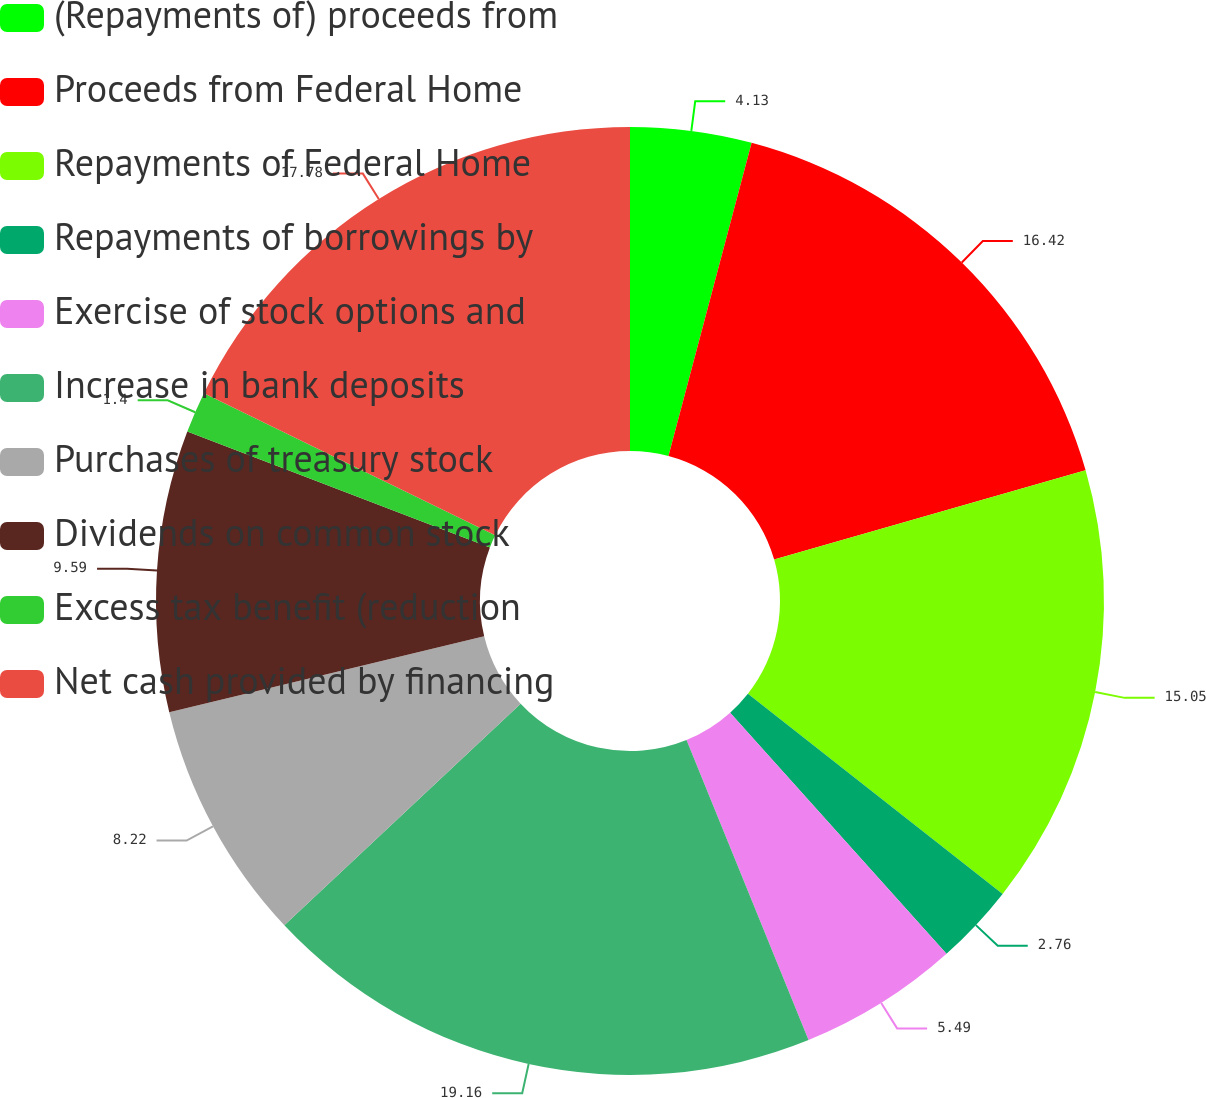Convert chart to OTSL. <chart><loc_0><loc_0><loc_500><loc_500><pie_chart><fcel>(Repayments of) proceeds from<fcel>Proceeds from Federal Home<fcel>Repayments of Federal Home<fcel>Repayments of borrowings by<fcel>Exercise of stock options and<fcel>Increase in bank deposits<fcel>Purchases of treasury stock<fcel>Dividends on common stock<fcel>Excess tax benefit (reduction<fcel>Net cash provided by financing<nl><fcel>4.13%<fcel>16.42%<fcel>15.05%<fcel>2.76%<fcel>5.49%<fcel>19.15%<fcel>8.22%<fcel>9.59%<fcel>1.4%<fcel>17.78%<nl></chart> 